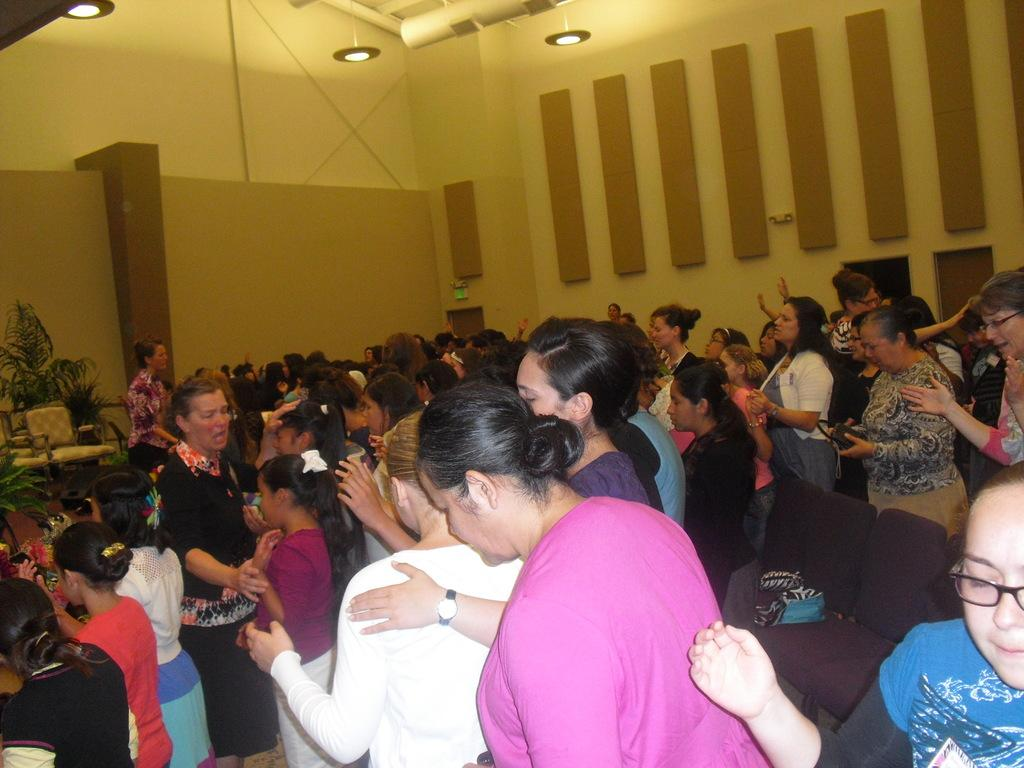What is the main focus of the image? The main focus of the image is the many people standing in the center. What can be seen in the background of the image? There is a wall in the background of the image. Is there any vegetation visible in the image? Yes, there is a plant to the left side of the image. What type of tin is being used by the parent in the image? There is no tin or parent present in the image. What kind of stone is visible on the ground in the image? The image does not show any stones on the ground; it only shows people, a wall, and a plant. 